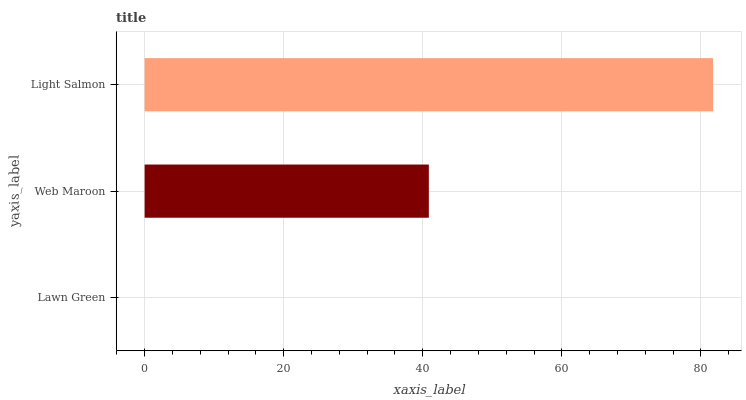Is Lawn Green the minimum?
Answer yes or no. Yes. Is Light Salmon the maximum?
Answer yes or no. Yes. Is Web Maroon the minimum?
Answer yes or no. No. Is Web Maroon the maximum?
Answer yes or no. No. Is Web Maroon greater than Lawn Green?
Answer yes or no. Yes. Is Lawn Green less than Web Maroon?
Answer yes or no. Yes. Is Lawn Green greater than Web Maroon?
Answer yes or no. No. Is Web Maroon less than Lawn Green?
Answer yes or no. No. Is Web Maroon the high median?
Answer yes or no. Yes. Is Web Maroon the low median?
Answer yes or no. Yes. Is Lawn Green the high median?
Answer yes or no. No. Is Light Salmon the low median?
Answer yes or no. No. 